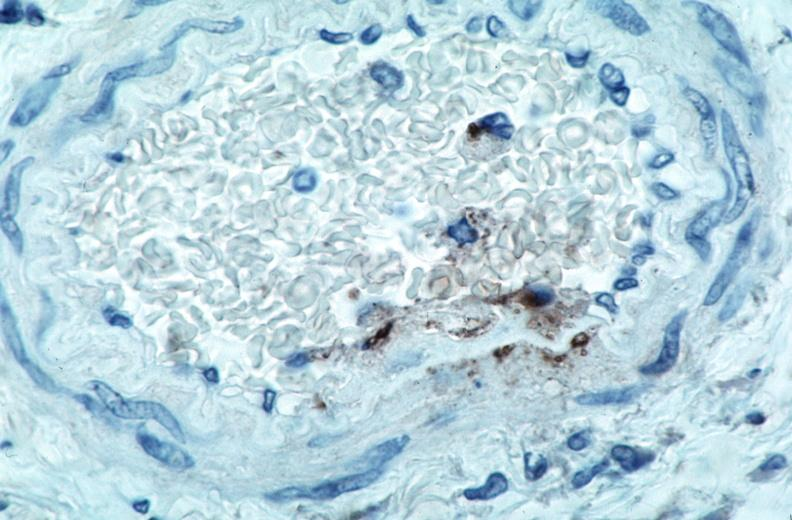s vasculature present?
Answer the question using a single word or phrase. Yes 